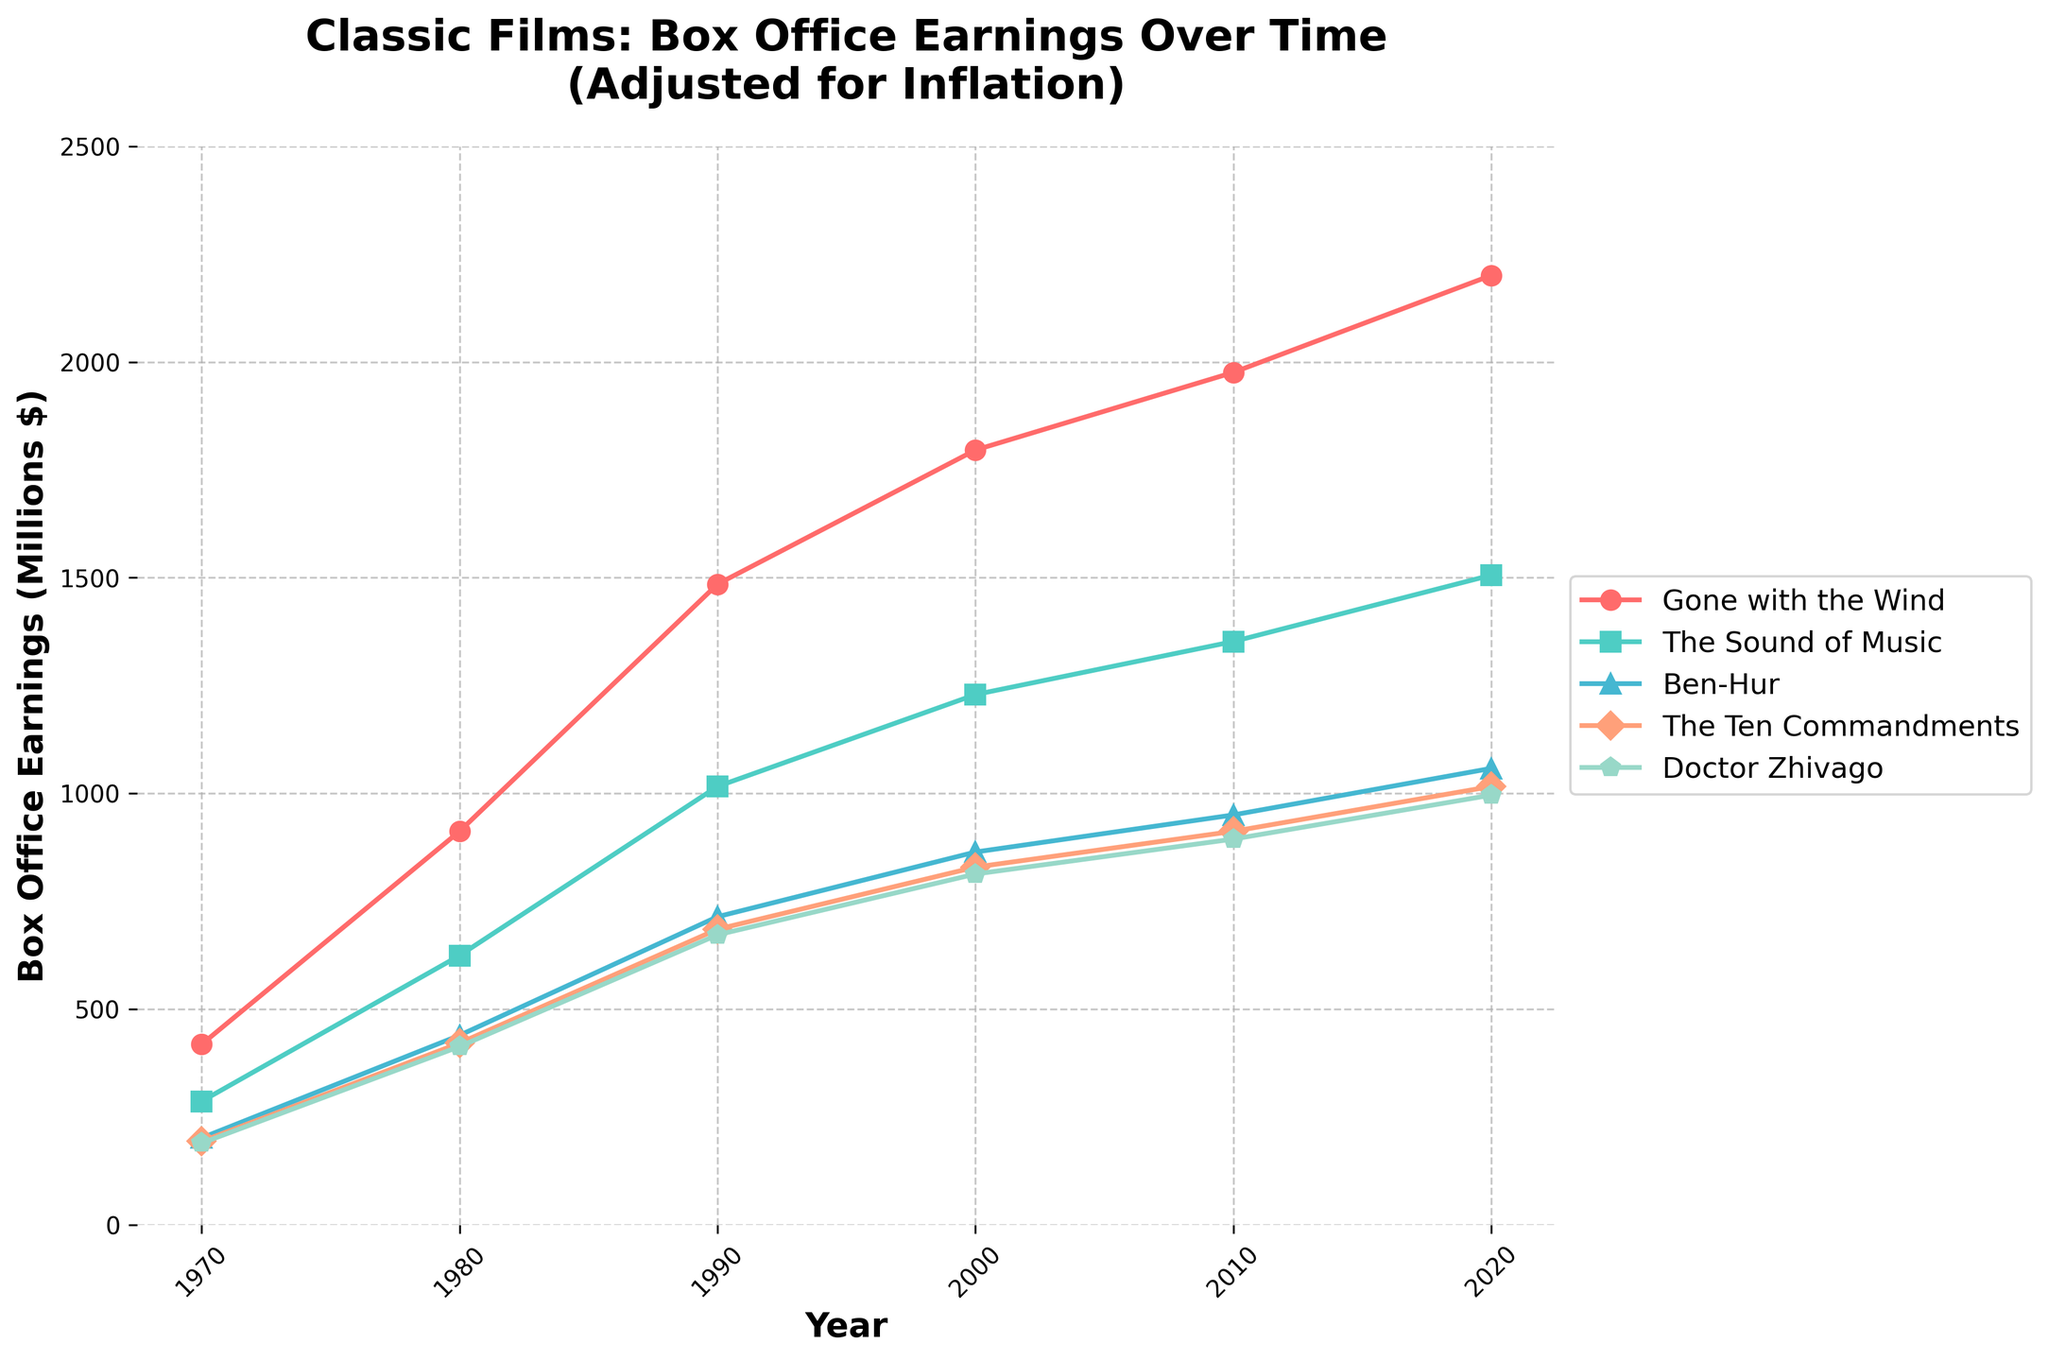What is the box office earning of "Gone with the Wind" in 1990? Locate the point on the line for "Gone with the Wind" at the year 1990 on the x-axis and read the corresponding value on the y-axis in millions.
Answer: 1485 million Which movie had the highest box office earnings in 2020? Compare the values for all the movies at the year 2020. "Gone with the Wind" has the highest value.
Answer: Gone with the Wind How much did "The Sound of Music" earn in 2000 compared to 1980? Subtract the value in 1980 from the value in 2000 for "The Sound of Music". 1229 million - 624 million = 605 million.
Answer: 605 million What is the trend pattern of "Ben-Hur" from 1970 to 2020? The trend can be inferred by observing the increasing values at every decade marker for "Ben-Hur". It shows a consistent upward trend.
Answer: Consistent upward By how much did the earnings of "The Ten Commandments" increase from 1970 to 2010? Subtract the value in 1970 from the value in 2010 for "The Ten Commandments". 912 million - 193 million = 719 million.
Answer: 719 million What is the average earning of "Doctor Zhivago" over the entire period? Sum all values across the years and then divide by the number of years. (189+413+672+813+894+996)/6 = 662.83 million.
Answer: 662.83 million Which movie had a steeper increase in earnings between 1980 and 2000, "Gone with the Wind" or "Ben-Hur"? Calculate the increase for both movies between 1980 and 2000. "Gone with the Wind": (1796-912) = 884 million. "Ben-Hur": (864-439) = 425 million. "Gone with the Wind" had a steeper increase.
Answer: Gone with the Wind Comparing "Doctor Zhivago" and "The Ten Commandments", which had higher earnings in 1990? Compare the height of the lines for "Doctor Zhivago" and "The Ten Commandments" at the year 1990. "The Ten Commandments" earned 685 million while "Doctor Zhivago" earned 672 million.
Answer: The Ten Commandments 